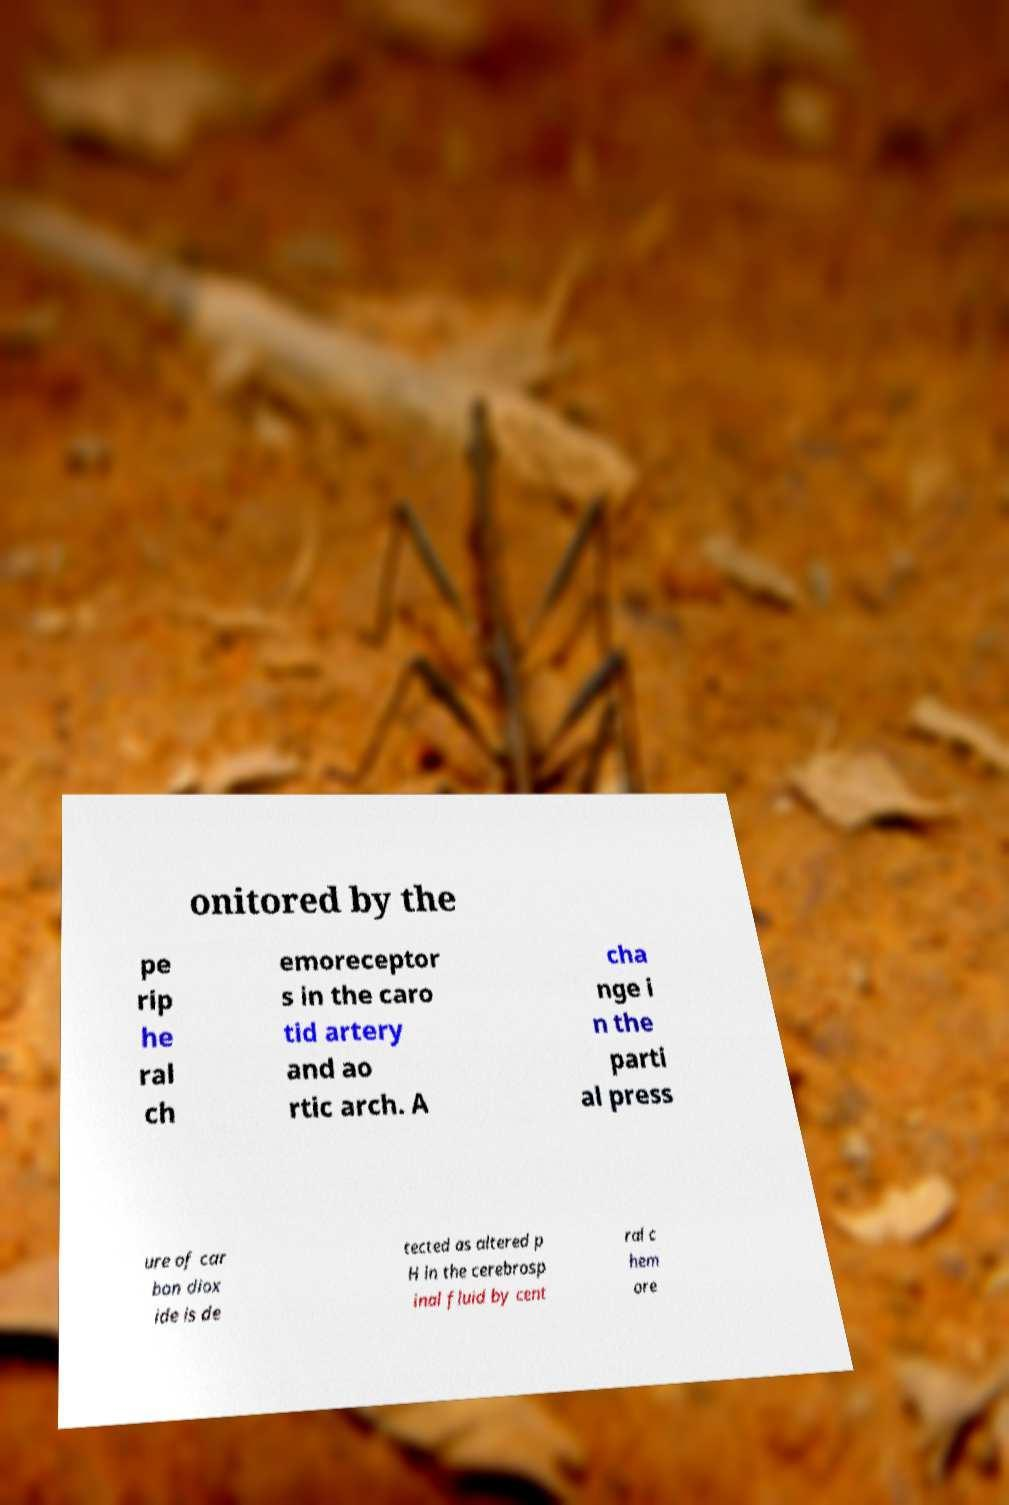Please read and relay the text visible in this image. What does it say? onitored by the pe rip he ral ch emoreceptor s in the caro tid artery and ao rtic arch. A cha nge i n the parti al press ure of car bon diox ide is de tected as altered p H in the cerebrosp inal fluid by cent ral c hem ore 